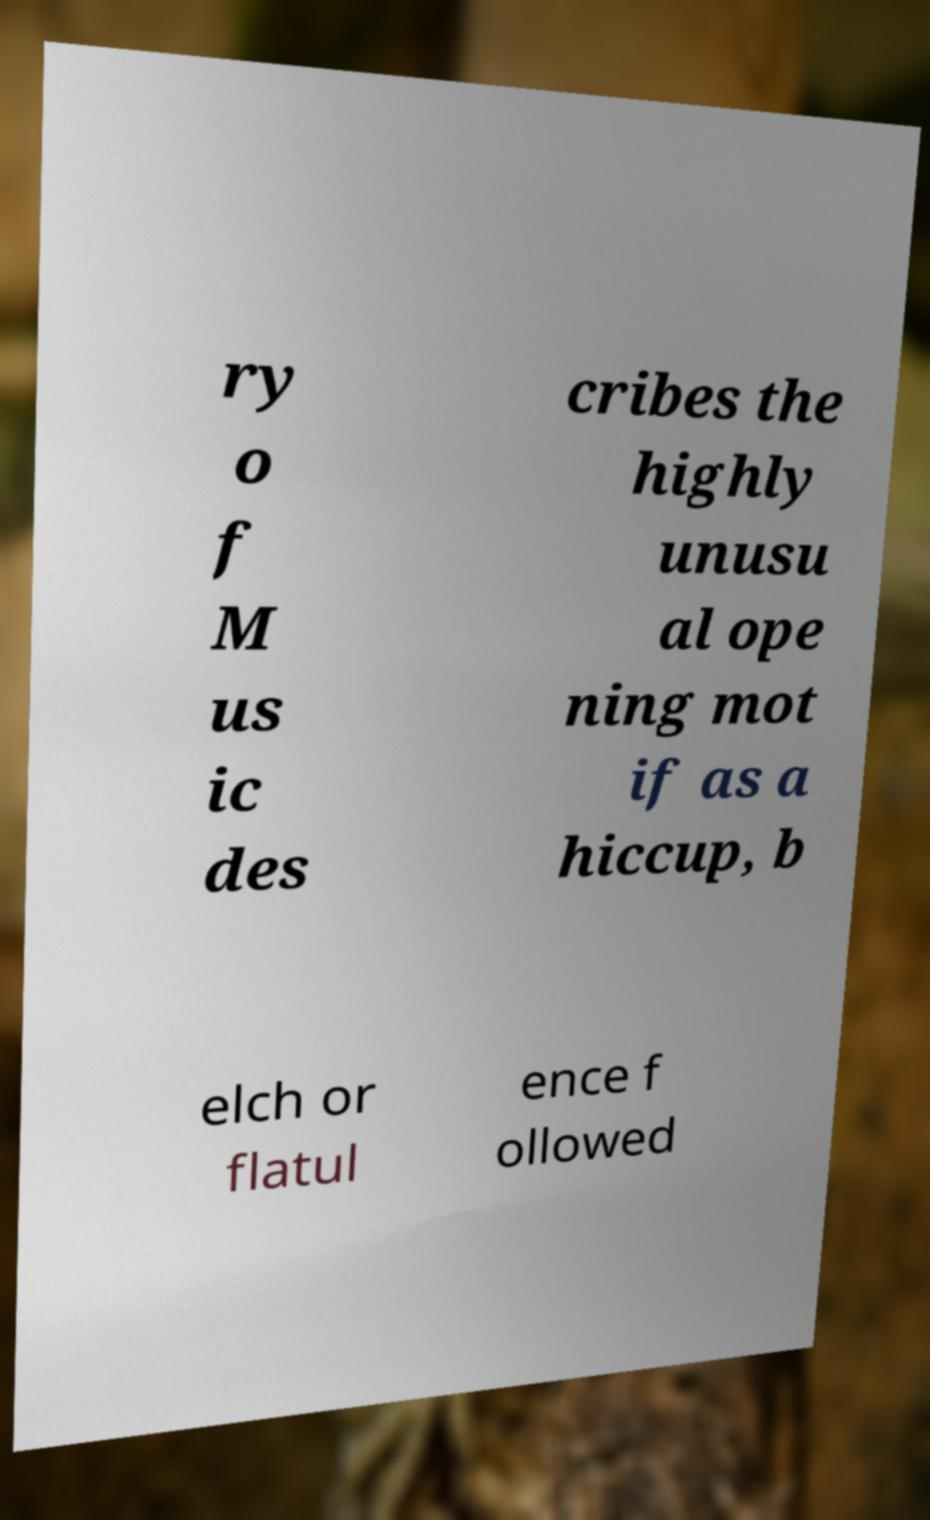What messages or text are displayed in this image? I need them in a readable, typed format. ry o f M us ic des cribes the highly unusu al ope ning mot if as a hiccup, b elch or flatul ence f ollowed 